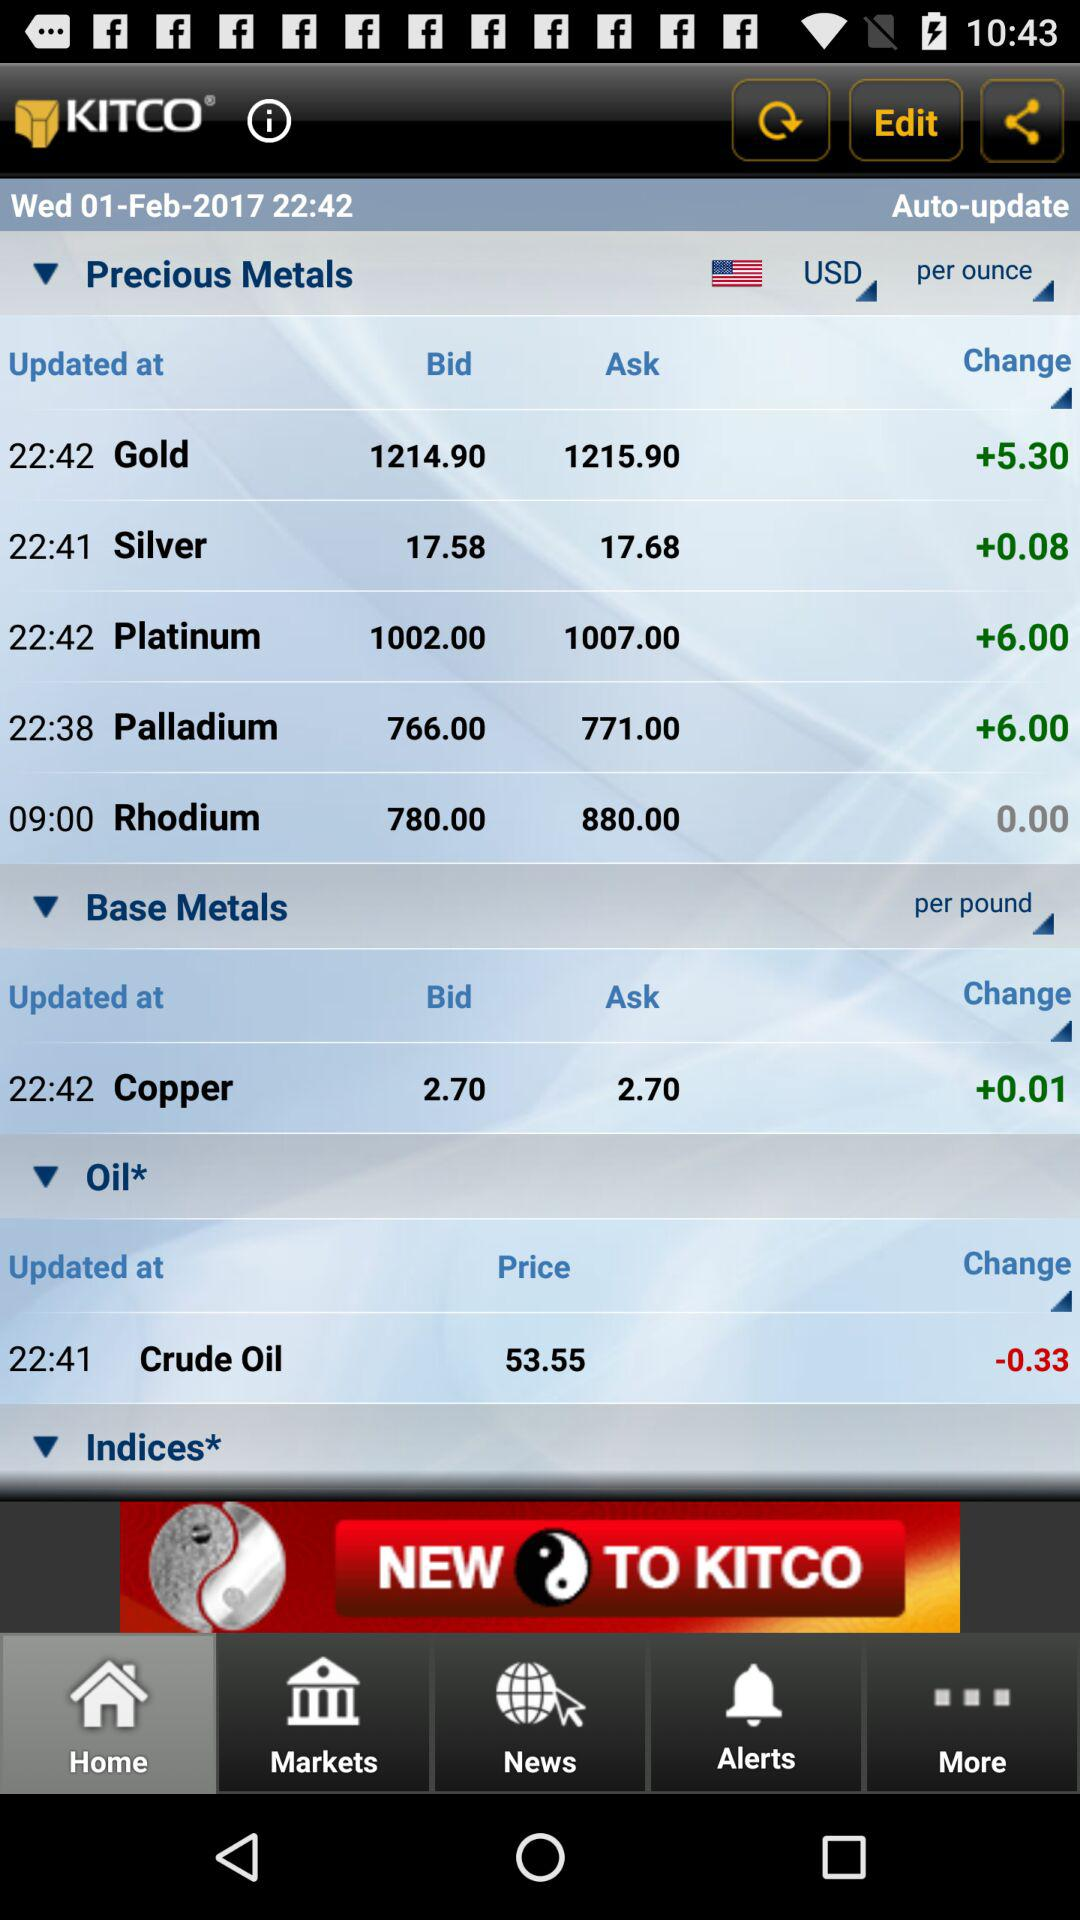What is the ask price of "Rhodium"? The ask price of "Rhodium" is 880 USD per ounce. 